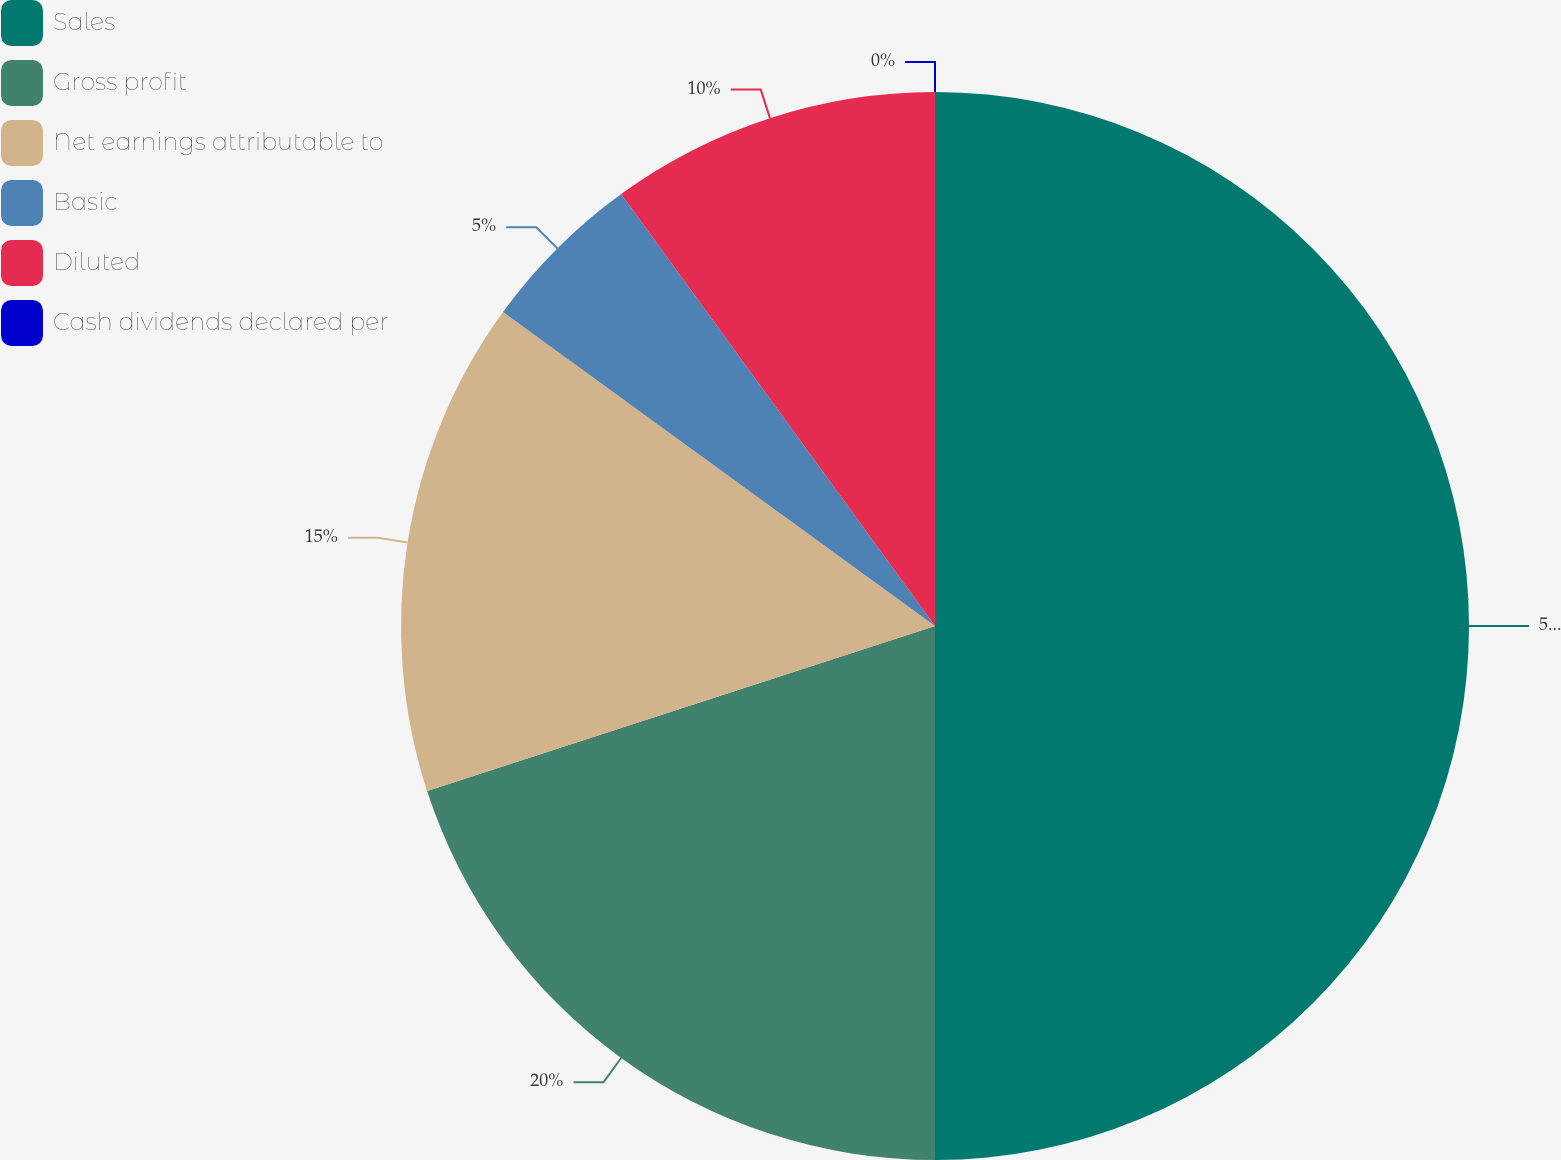<chart> <loc_0><loc_0><loc_500><loc_500><pie_chart><fcel>Sales<fcel>Gross profit<fcel>Net earnings attributable to<fcel>Basic<fcel>Diluted<fcel>Cash dividends declared per<nl><fcel>50.0%<fcel>20.0%<fcel>15.0%<fcel>5.0%<fcel>10.0%<fcel>0.0%<nl></chart> 